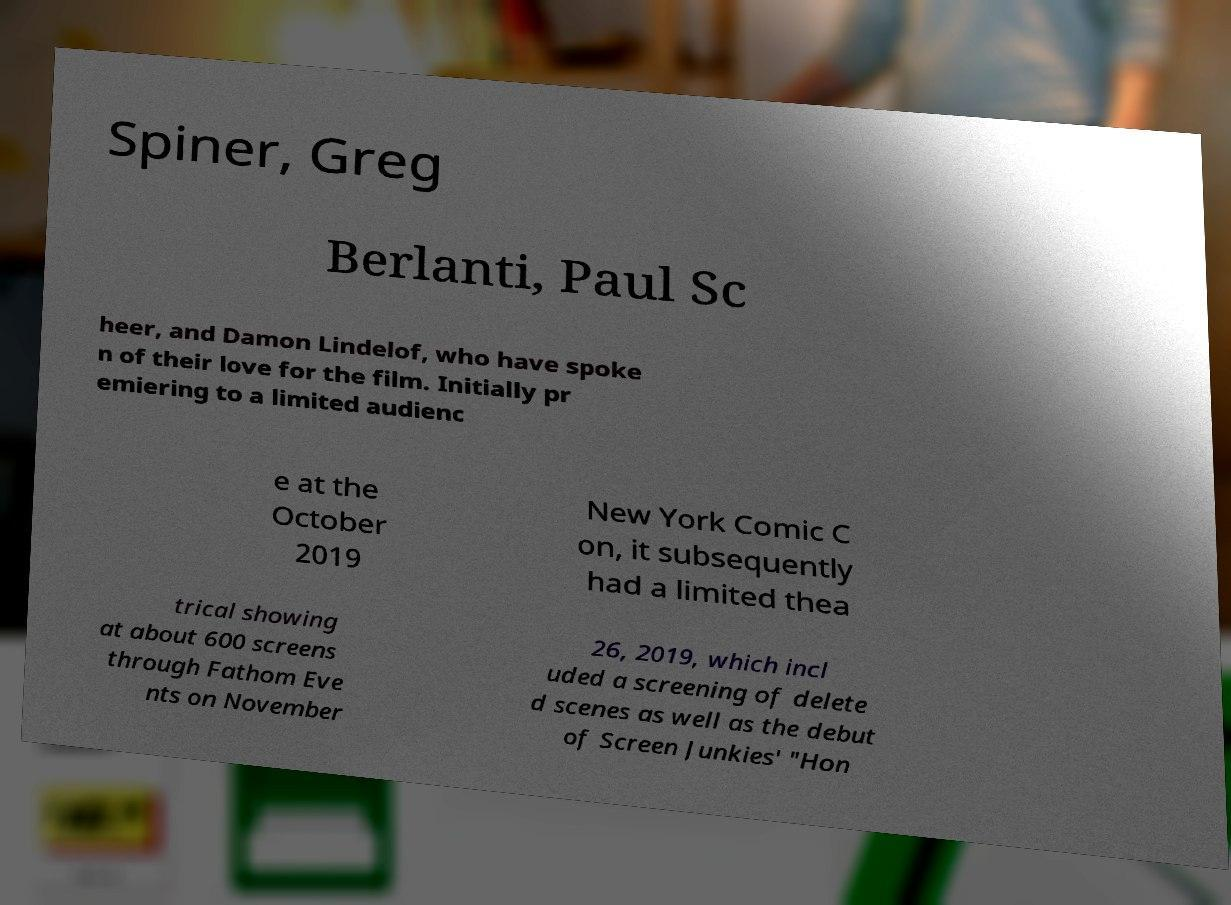Can you accurately transcribe the text from the provided image for me? Spiner, Greg Berlanti, Paul Sc heer, and Damon Lindelof, who have spoke n of their love for the film. Initially pr emiering to a limited audienc e at the October 2019 New York Comic C on, it subsequently had a limited thea trical showing at about 600 screens through Fathom Eve nts on November 26, 2019, which incl uded a screening of delete d scenes as well as the debut of Screen Junkies' "Hon 